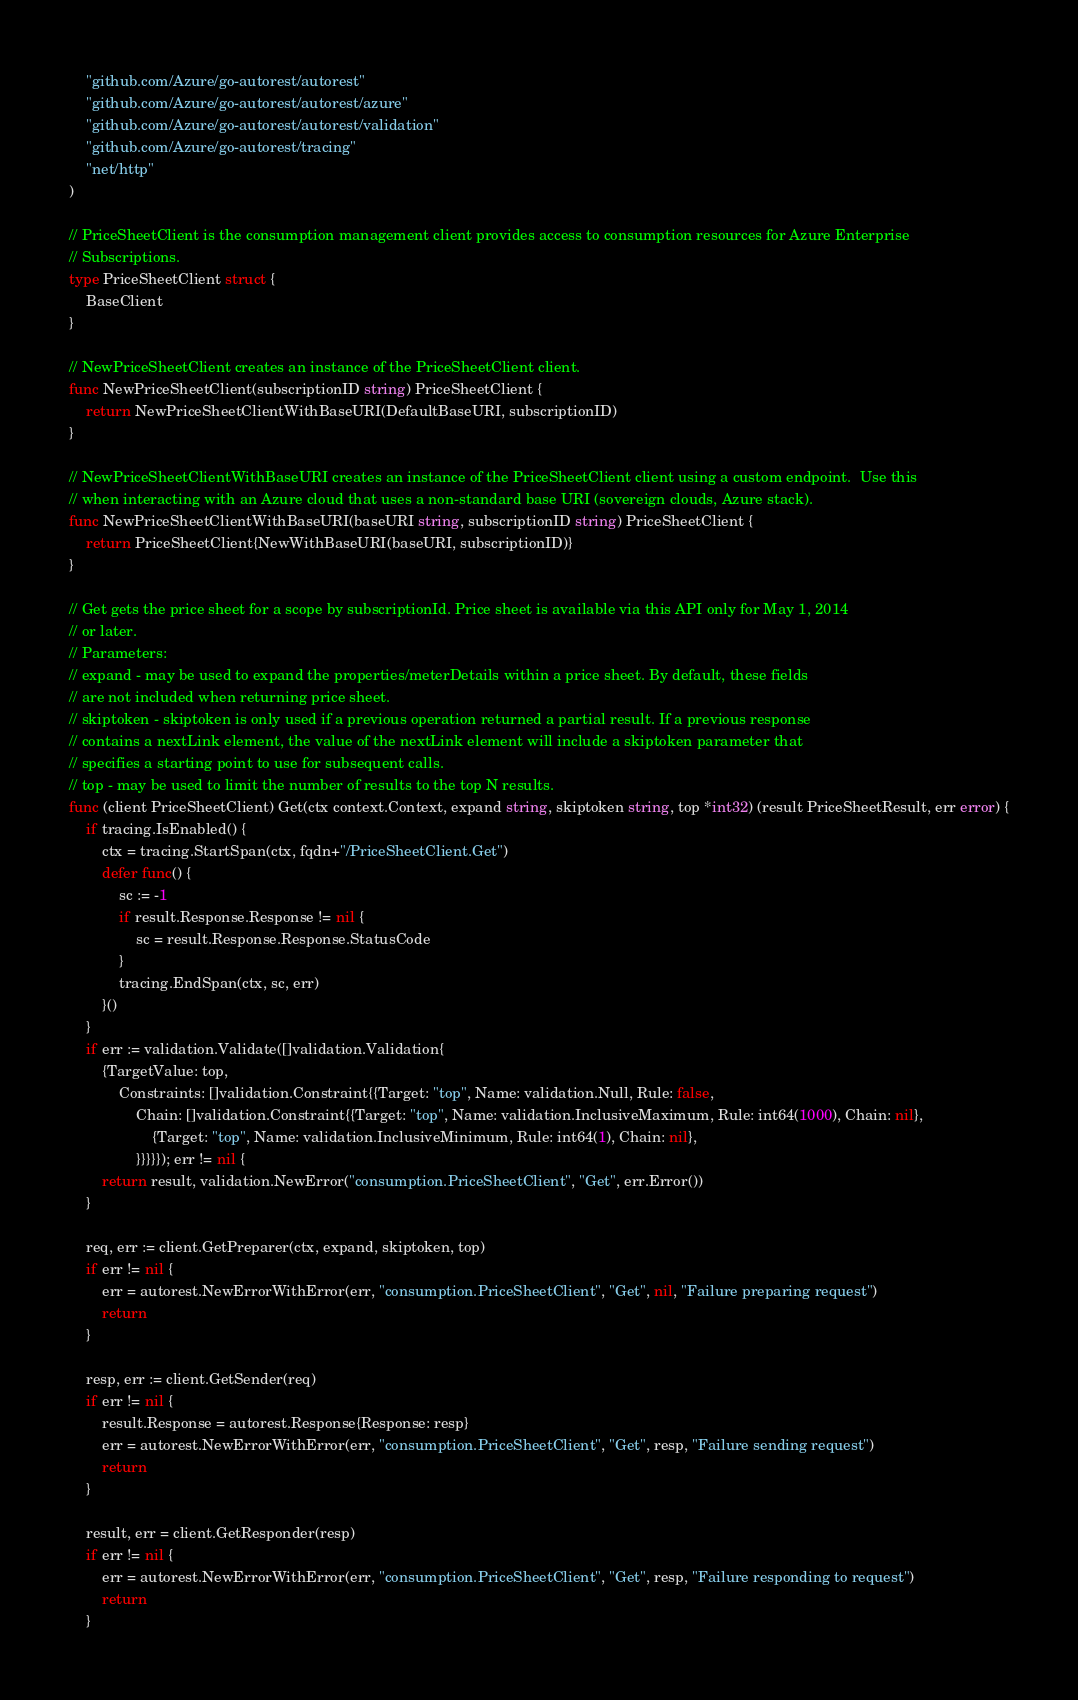<code> <loc_0><loc_0><loc_500><loc_500><_Go_>	"github.com/Azure/go-autorest/autorest"
	"github.com/Azure/go-autorest/autorest/azure"
	"github.com/Azure/go-autorest/autorest/validation"
	"github.com/Azure/go-autorest/tracing"
	"net/http"
)

// PriceSheetClient is the consumption management client provides access to consumption resources for Azure Enterprise
// Subscriptions.
type PriceSheetClient struct {
	BaseClient
}

// NewPriceSheetClient creates an instance of the PriceSheetClient client.
func NewPriceSheetClient(subscriptionID string) PriceSheetClient {
	return NewPriceSheetClientWithBaseURI(DefaultBaseURI, subscriptionID)
}

// NewPriceSheetClientWithBaseURI creates an instance of the PriceSheetClient client using a custom endpoint.  Use this
// when interacting with an Azure cloud that uses a non-standard base URI (sovereign clouds, Azure stack).
func NewPriceSheetClientWithBaseURI(baseURI string, subscriptionID string) PriceSheetClient {
	return PriceSheetClient{NewWithBaseURI(baseURI, subscriptionID)}
}

// Get gets the price sheet for a scope by subscriptionId. Price sheet is available via this API only for May 1, 2014
// or later.
// Parameters:
// expand - may be used to expand the properties/meterDetails within a price sheet. By default, these fields
// are not included when returning price sheet.
// skiptoken - skiptoken is only used if a previous operation returned a partial result. If a previous response
// contains a nextLink element, the value of the nextLink element will include a skiptoken parameter that
// specifies a starting point to use for subsequent calls.
// top - may be used to limit the number of results to the top N results.
func (client PriceSheetClient) Get(ctx context.Context, expand string, skiptoken string, top *int32) (result PriceSheetResult, err error) {
	if tracing.IsEnabled() {
		ctx = tracing.StartSpan(ctx, fqdn+"/PriceSheetClient.Get")
		defer func() {
			sc := -1
			if result.Response.Response != nil {
				sc = result.Response.Response.StatusCode
			}
			tracing.EndSpan(ctx, sc, err)
		}()
	}
	if err := validation.Validate([]validation.Validation{
		{TargetValue: top,
			Constraints: []validation.Constraint{{Target: "top", Name: validation.Null, Rule: false,
				Chain: []validation.Constraint{{Target: "top", Name: validation.InclusiveMaximum, Rule: int64(1000), Chain: nil},
					{Target: "top", Name: validation.InclusiveMinimum, Rule: int64(1), Chain: nil},
				}}}}}); err != nil {
		return result, validation.NewError("consumption.PriceSheetClient", "Get", err.Error())
	}

	req, err := client.GetPreparer(ctx, expand, skiptoken, top)
	if err != nil {
		err = autorest.NewErrorWithError(err, "consumption.PriceSheetClient", "Get", nil, "Failure preparing request")
		return
	}

	resp, err := client.GetSender(req)
	if err != nil {
		result.Response = autorest.Response{Response: resp}
		err = autorest.NewErrorWithError(err, "consumption.PriceSheetClient", "Get", resp, "Failure sending request")
		return
	}

	result, err = client.GetResponder(resp)
	if err != nil {
		err = autorest.NewErrorWithError(err, "consumption.PriceSheetClient", "Get", resp, "Failure responding to request")
		return
	}
</code> 